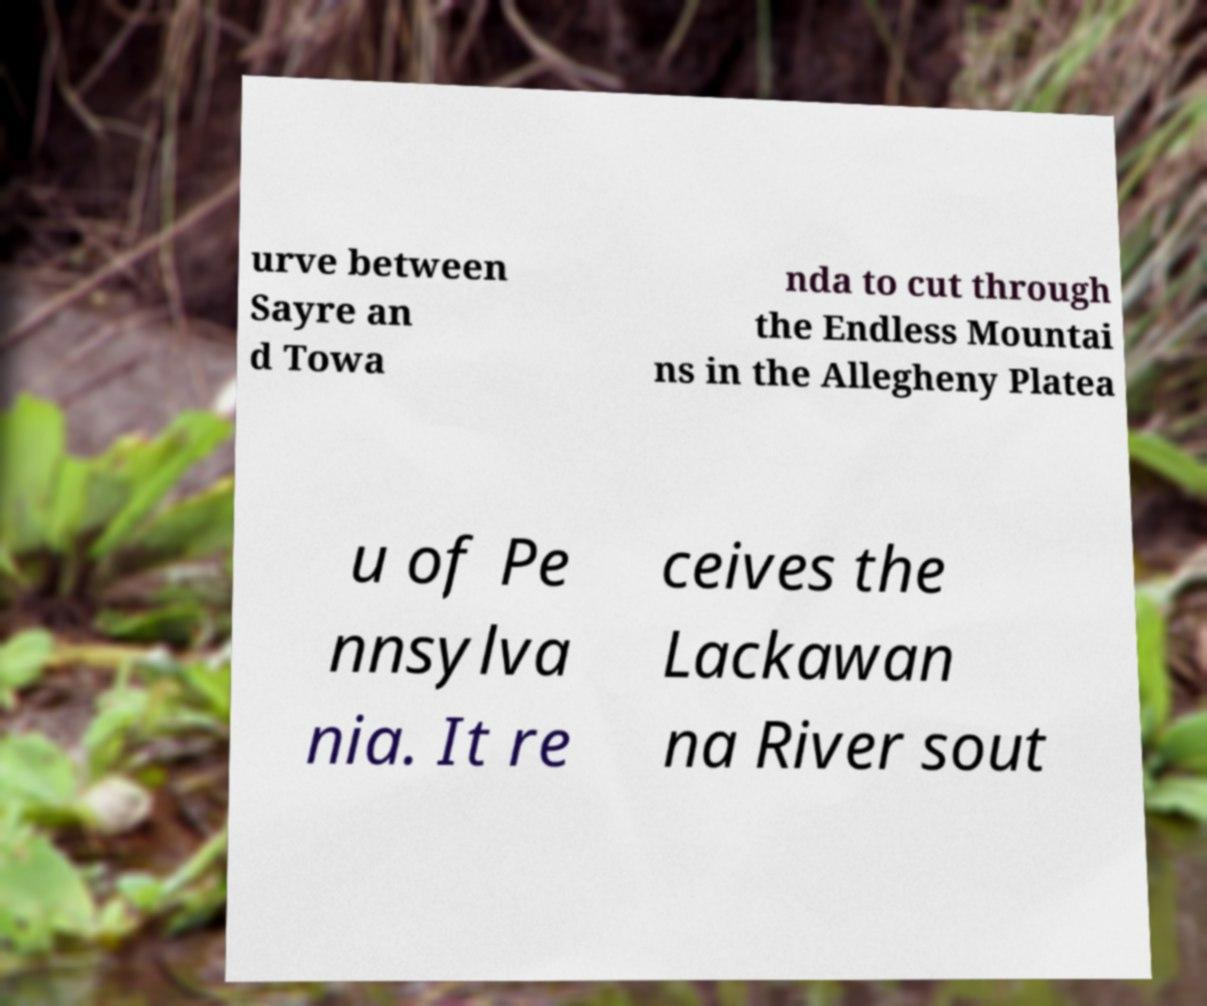For documentation purposes, I need the text within this image transcribed. Could you provide that? urve between Sayre an d Towa nda to cut through the Endless Mountai ns in the Allegheny Platea u of Pe nnsylva nia. It re ceives the Lackawan na River sout 